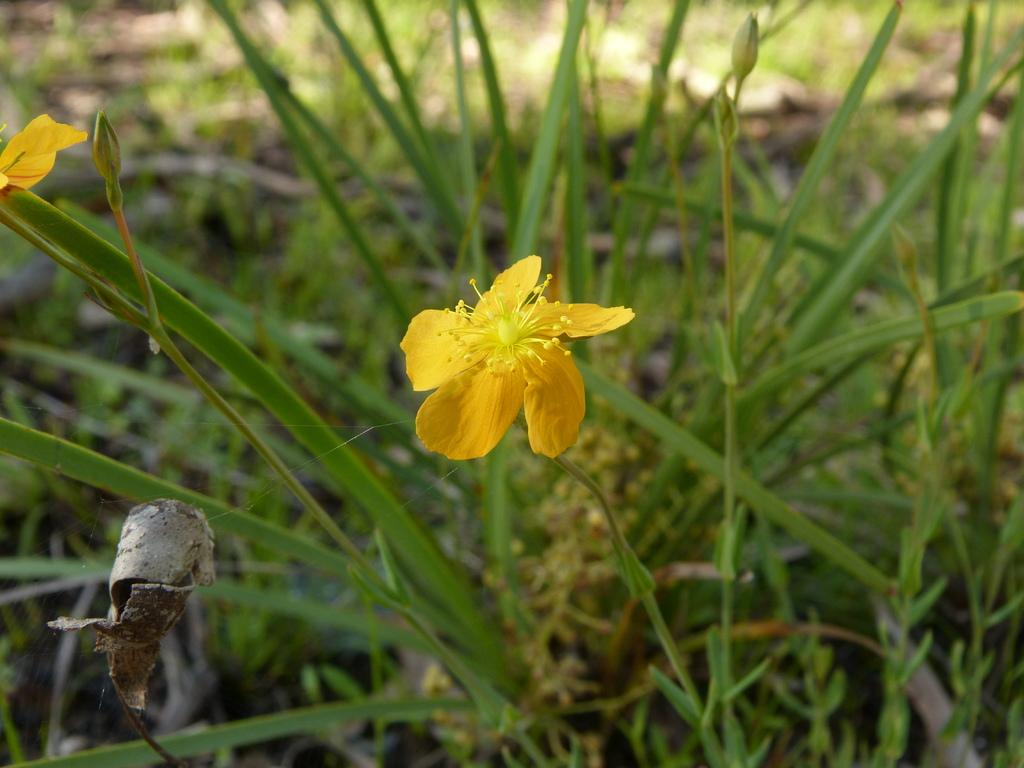What type of flower is present in the image? There is a yellow flower in the image. What can be seen in the background of the image? There are green plants in the background of the image. Can you see a kitty playing near the yellow flower in the image? There is no kitty present in the image; it only features a yellow flower and green plants in the background. 